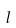Convert formula to latex. <formula><loc_0><loc_0><loc_500><loc_500>l</formula> 